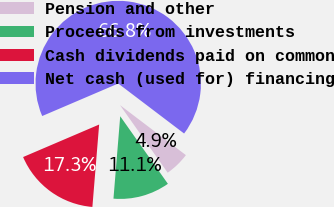Convert chart to OTSL. <chart><loc_0><loc_0><loc_500><loc_500><pie_chart><fcel>Pension and other<fcel>Proceeds from investments<fcel>Cash dividends paid on common<fcel>Net cash (used for) financing<nl><fcel>4.89%<fcel>11.08%<fcel>17.27%<fcel>66.76%<nl></chart> 